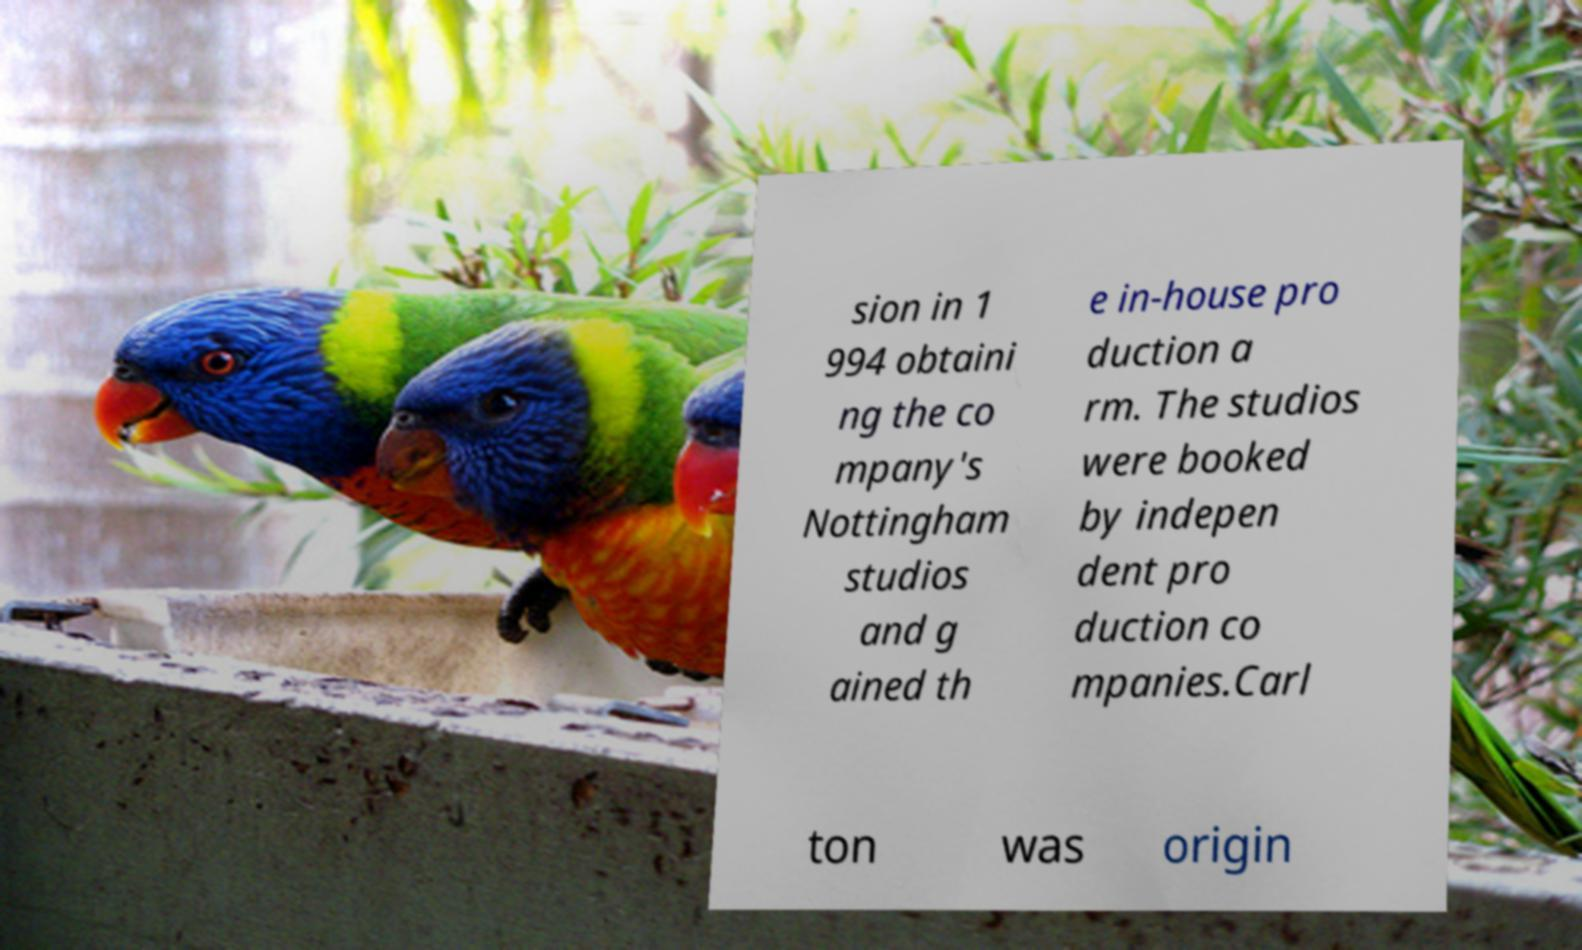What messages or text are displayed in this image? I need them in a readable, typed format. sion in 1 994 obtaini ng the co mpany's Nottingham studios and g ained th e in-house pro duction a rm. The studios were booked by indepen dent pro duction co mpanies.Carl ton was origin 